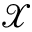Convert formula to latex. <formula><loc_0><loc_0><loc_500><loc_500>\mathcal { X }</formula> 